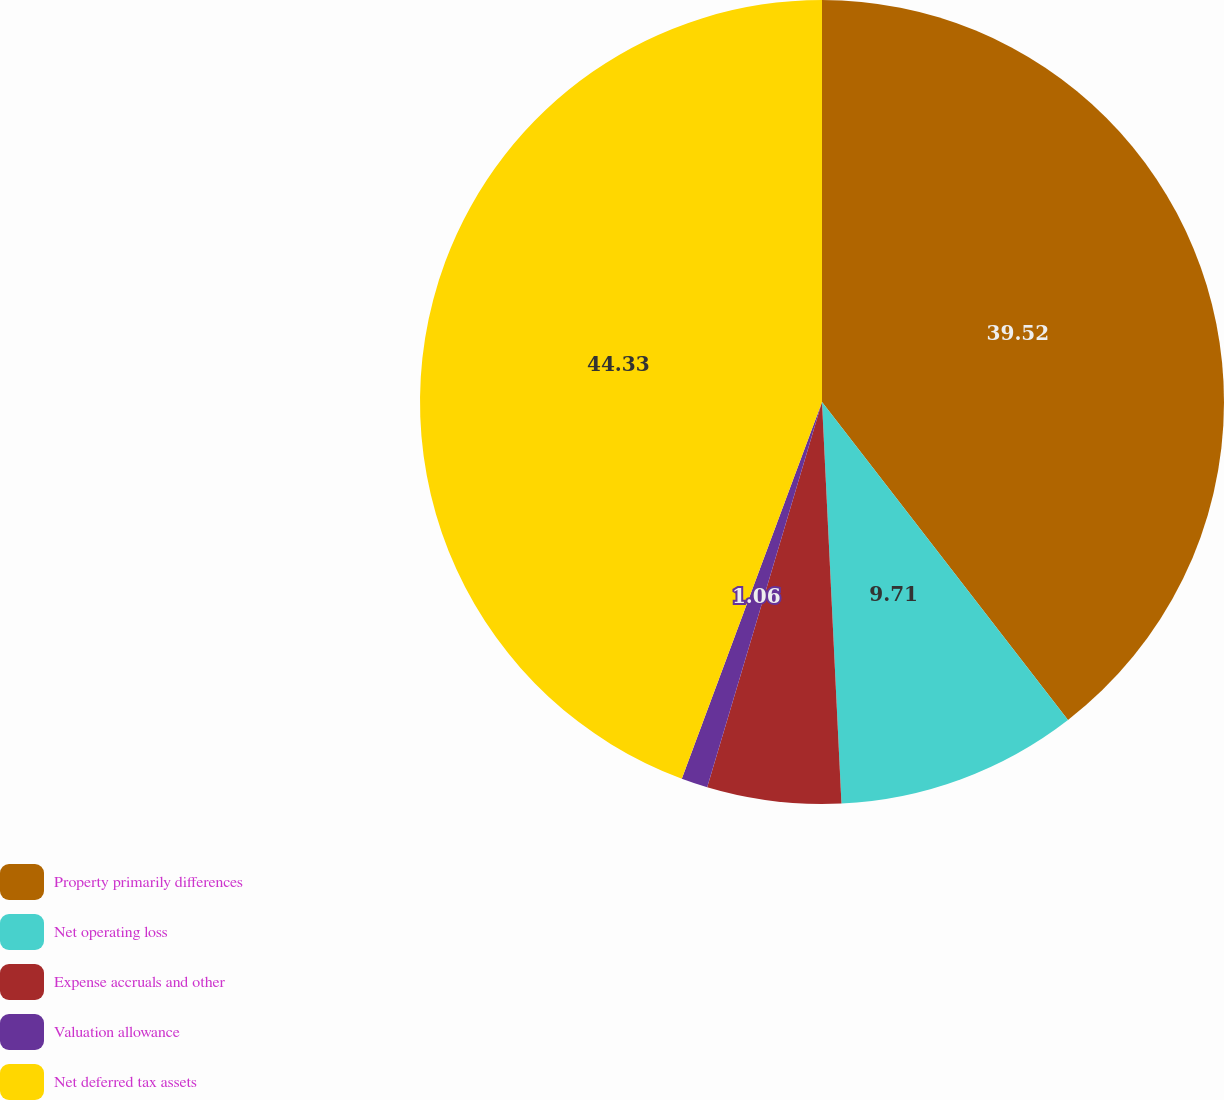<chart> <loc_0><loc_0><loc_500><loc_500><pie_chart><fcel>Property primarily differences<fcel>Net operating loss<fcel>Expense accruals and other<fcel>Valuation allowance<fcel>Net deferred tax assets<nl><fcel>39.52%<fcel>9.71%<fcel>5.38%<fcel>1.06%<fcel>44.33%<nl></chart> 